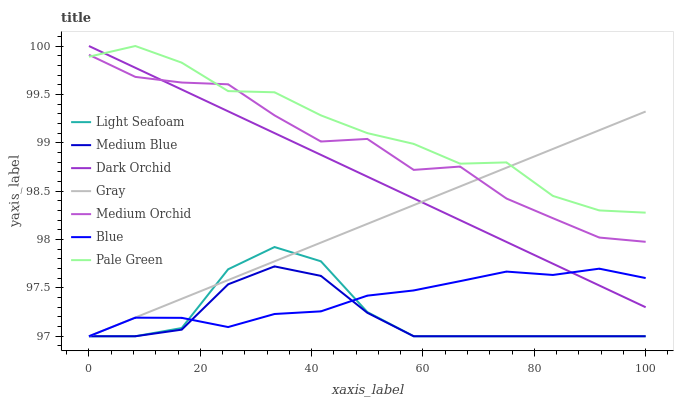Does Gray have the minimum area under the curve?
Answer yes or no. No. Does Gray have the maximum area under the curve?
Answer yes or no. No. Is Medium Orchid the smoothest?
Answer yes or no. No. Is Medium Orchid the roughest?
Answer yes or no. No. Does Medium Orchid have the lowest value?
Answer yes or no. No. Does Gray have the highest value?
Answer yes or no. No. Is Blue less than Medium Orchid?
Answer yes or no. Yes. Is Medium Orchid greater than Medium Blue?
Answer yes or no. Yes. Does Blue intersect Medium Orchid?
Answer yes or no. No. 